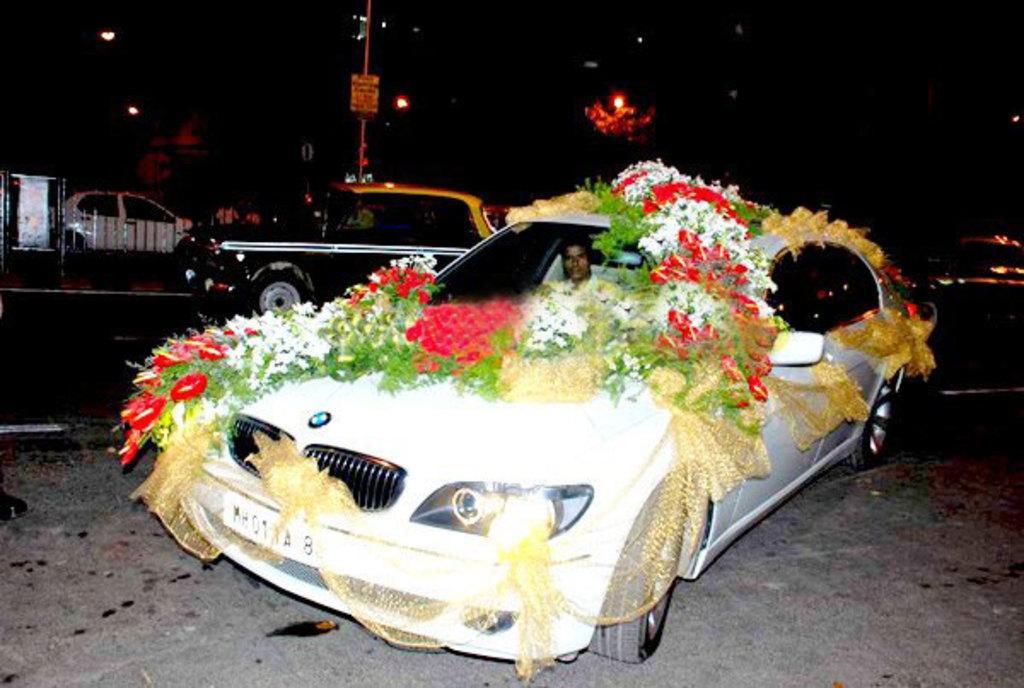Describe this image in one or two sentences. This image is taken during night time. In this image we can see a man in the decorated car. In the background we can see the vehicles and also the fence and lights and also the pole. 